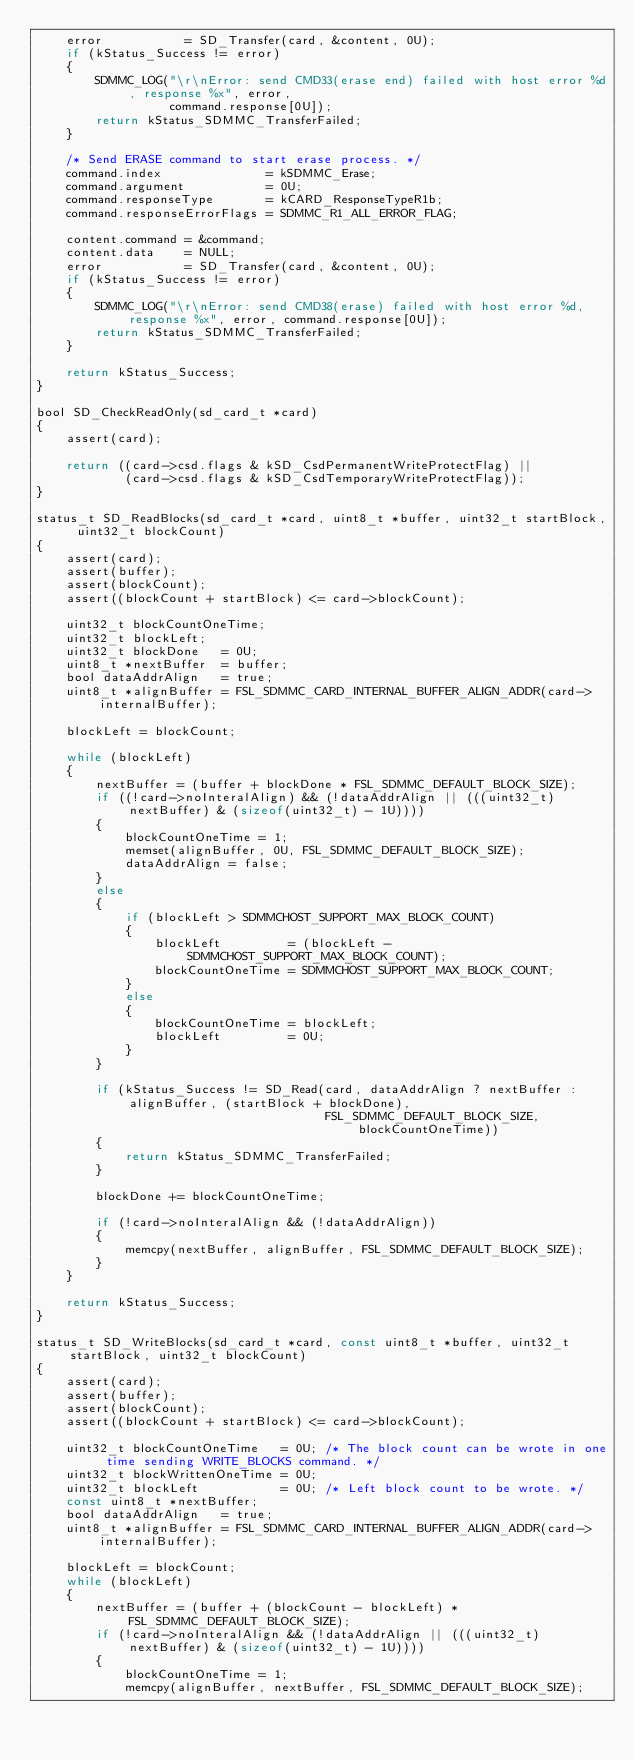Convert code to text. <code><loc_0><loc_0><loc_500><loc_500><_C_>    error           = SD_Transfer(card, &content, 0U);
    if (kStatus_Success != error)
    {
        SDMMC_LOG("\r\nError: send CMD33(erase end) failed with host error %d, response %x", error,
                  command.response[0U]);
        return kStatus_SDMMC_TransferFailed;
    }

    /* Send ERASE command to start erase process. */
    command.index              = kSDMMC_Erase;
    command.argument           = 0U;
    command.responseType       = kCARD_ResponseTypeR1b;
    command.responseErrorFlags = SDMMC_R1_ALL_ERROR_FLAG;

    content.command = &command;
    content.data    = NULL;
    error           = SD_Transfer(card, &content, 0U);
    if (kStatus_Success != error)
    {
        SDMMC_LOG("\r\nError: send CMD38(erase) failed with host error %d, response %x", error, command.response[0U]);
        return kStatus_SDMMC_TransferFailed;
    }

    return kStatus_Success;
}

bool SD_CheckReadOnly(sd_card_t *card)
{
    assert(card);

    return ((card->csd.flags & kSD_CsdPermanentWriteProtectFlag) ||
            (card->csd.flags & kSD_CsdTemporaryWriteProtectFlag));
}

status_t SD_ReadBlocks(sd_card_t *card, uint8_t *buffer, uint32_t startBlock, uint32_t blockCount)
{
    assert(card);
    assert(buffer);
    assert(blockCount);
    assert((blockCount + startBlock) <= card->blockCount);

    uint32_t blockCountOneTime;
    uint32_t blockLeft;
    uint32_t blockDone   = 0U;
    uint8_t *nextBuffer  = buffer;
    bool dataAddrAlign   = true;
    uint8_t *alignBuffer = FSL_SDMMC_CARD_INTERNAL_BUFFER_ALIGN_ADDR(card->internalBuffer);

    blockLeft = blockCount;

    while (blockLeft)
    {
        nextBuffer = (buffer + blockDone * FSL_SDMMC_DEFAULT_BLOCK_SIZE);
        if ((!card->noInteralAlign) && (!dataAddrAlign || (((uint32_t)nextBuffer) & (sizeof(uint32_t) - 1U))))
        {
            blockCountOneTime = 1;
            memset(alignBuffer, 0U, FSL_SDMMC_DEFAULT_BLOCK_SIZE);
            dataAddrAlign = false;
        }
        else
        {
            if (blockLeft > SDMMCHOST_SUPPORT_MAX_BLOCK_COUNT)
            {
                blockLeft         = (blockLeft - SDMMCHOST_SUPPORT_MAX_BLOCK_COUNT);
                blockCountOneTime = SDMMCHOST_SUPPORT_MAX_BLOCK_COUNT;
            }
            else
            {
                blockCountOneTime = blockLeft;
                blockLeft         = 0U;
            }
        }

        if (kStatus_Success != SD_Read(card, dataAddrAlign ? nextBuffer : alignBuffer, (startBlock + blockDone),
                                       FSL_SDMMC_DEFAULT_BLOCK_SIZE, blockCountOneTime))
        {
            return kStatus_SDMMC_TransferFailed;
        }

        blockDone += blockCountOneTime;

        if (!card->noInteralAlign && (!dataAddrAlign))
        {
            memcpy(nextBuffer, alignBuffer, FSL_SDMMC_DEFAULT_BLOCK_SIZE);
        }
    }

    return kStatus_Success;
}

status_t SD_WriteBlocks(sd_card_t *card, const uint8_t *buffer, uint32_t startBlock, uint32_t blockCount)
{
    assert(card);
    assert(buffer);
    assert(blockCount);
    assert((blockCount + startBlock) <= card->blockCount);

    uint32_t blockCountOneTime   = 0U; /* The block count can be wrote in one time sending WRITE_BLOCKS command. */
    uint32_t blockWrittenOneTime = 0U;
    uint32_t blockLeft           = 0U; /* Left block count to be wrote. */
    const uint8_t *nextBuffer;
    bool dataAddrAlign   = true;
    uint8_t *alignBuffer = FSL_SDMMC_CARD_INTERNAL_BUFFER_ALIGN_ADDR(card->internalBuffer);

    blockLeft = blockCount;
    while (blockLeft)
    {
        nextBuffer = (buffer + (blockCount - blockLeft) * FSL_SDMMC_DEFAULT_BLOCK_SIZE);
        if (!card->noInteralAlign && (!dataAddrAlign || (((uint32_t)nextBuffer) & (sizeof(uint32_t) - 1U))))
        {
            blockCountOneTime = 1;
            memcpy(alignBuffer, nextBuffer, FSL_SDMMC_DEFAULT_BLOCK_SIZE);</code> 